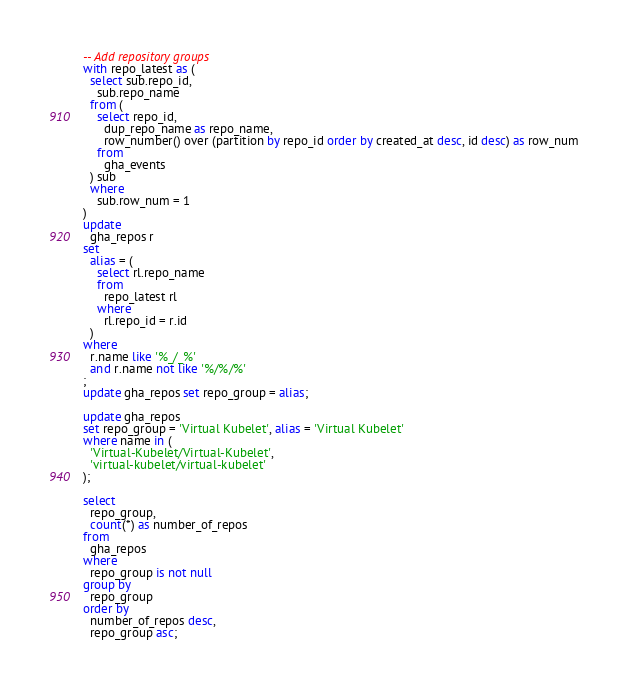<code> <loc_0><loc_0><loc_500><loc_500><_SQL_>-- Add repository groups
with repo_latest as (
  select sub.repo_id,
    sub.repo_name
  from (
    select repo_id,
      dup_repo_name as repo_name,
      row_number() over (partition by repo_id order by created_at desc, id desc) as row_num
    from
      gha_events
  ) sub
  where
    sub.row_num = 1
)
update
  gha_repos r
set
  alias = (
    select rl.repo_name
    from
      repo_latest rl
    where
      rl.repo_id = r.id
  )
where
  r.name like '%_/_%'
  and r.name not like '%/%/%'
;
update gha_repos set repo_group = alias;

update gha_repos
set repo_group = 'Virtual Kubelet', alias = 'Virtual Kubelet'
where name in (
  'Virtual-Kubelet/Virtual-Kubelet',
  'virtual-kubelet/virtual-kubelet'
);

select
  repo_group,
  count(*) as number_of_repos
from
  gha_repos
where
  repo_group is not null
group by
  repo_group
order by
  number_of_repos desc,
  repo_group asc;
</code> 